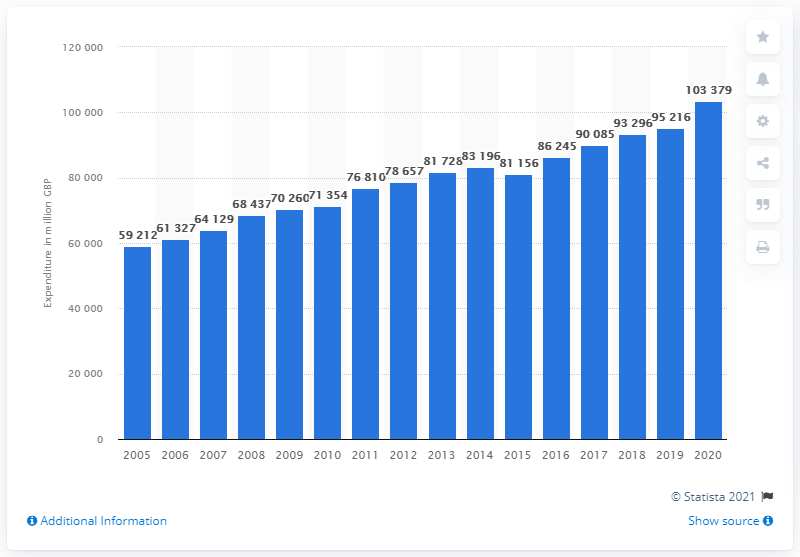Highlight a few significant elements in this photo. In 2020, the total amount of money spent by consumers on food in the UK was 103,379. 